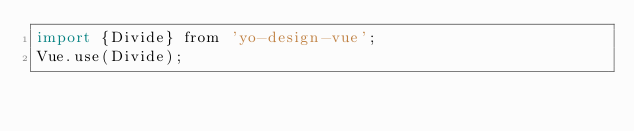Convert code to text. <code><loc_0><loc_0><loc_500><loc_500><_JavaScript_>import {Divide} from 'yo-design-vue';
Vue.use(Divide);</code> 